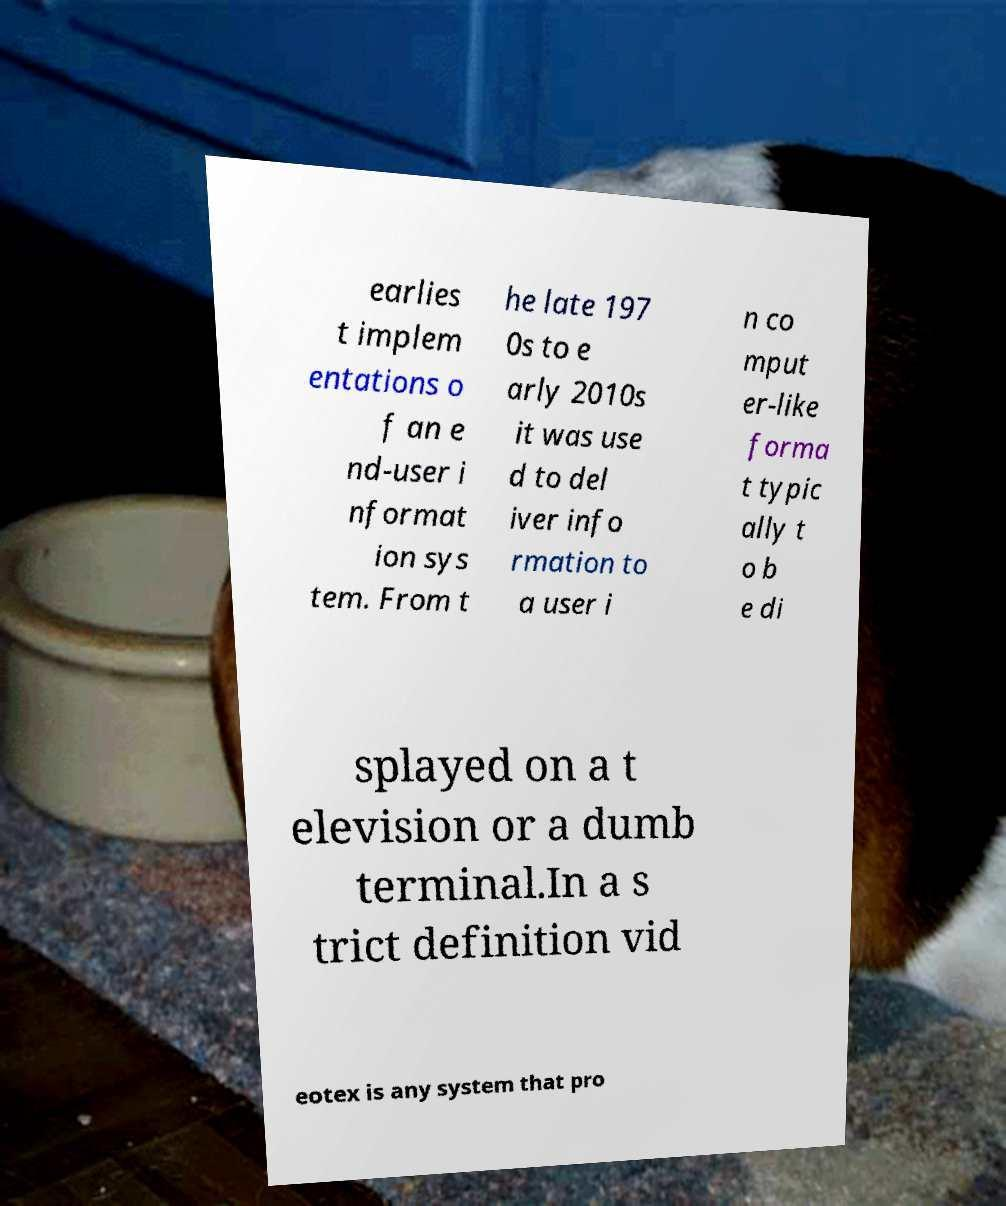Could you extract and type out the text from this image? earlies t implem entations o f an e nd-user i nformat ion sys tem. From t he late 197 0s to e arly 2010s it was use d to del iver info rmation to a user i n co mput er-like forma t typic ally t o b e di splayed on a t elevision or a dumb terminal.In a s trict definition vid eotex is any system that pro 